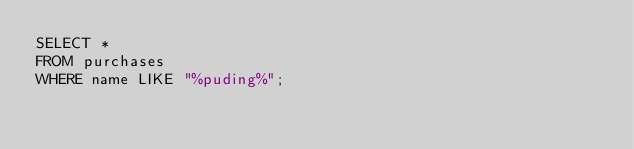Convert code to text. <code><loc_0><loc_0><loc_500><loc_500><_SQL_>SELECT *
FROM purchases
WHERE name LIKE "%puding%";</code> 